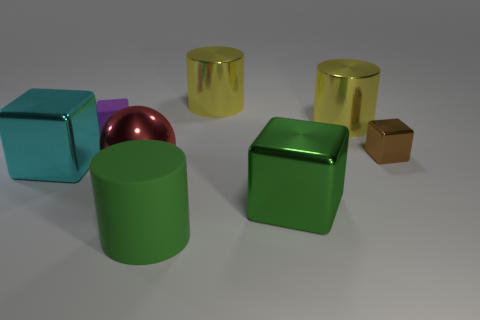Add 1 matte cylinders. How many objects exist? 9 Subtract all balls. How many objects are left? 7 Add 4 blocks. How many blocks are left? 8 Add 8 metal cylinders. How many metal cylinders exist? 10 Subtract 1 purple blocks. How many objects are left? 7 Subtract all big cyan metallic objects. Subtract all red metal spheres. How many objects are left? 6 